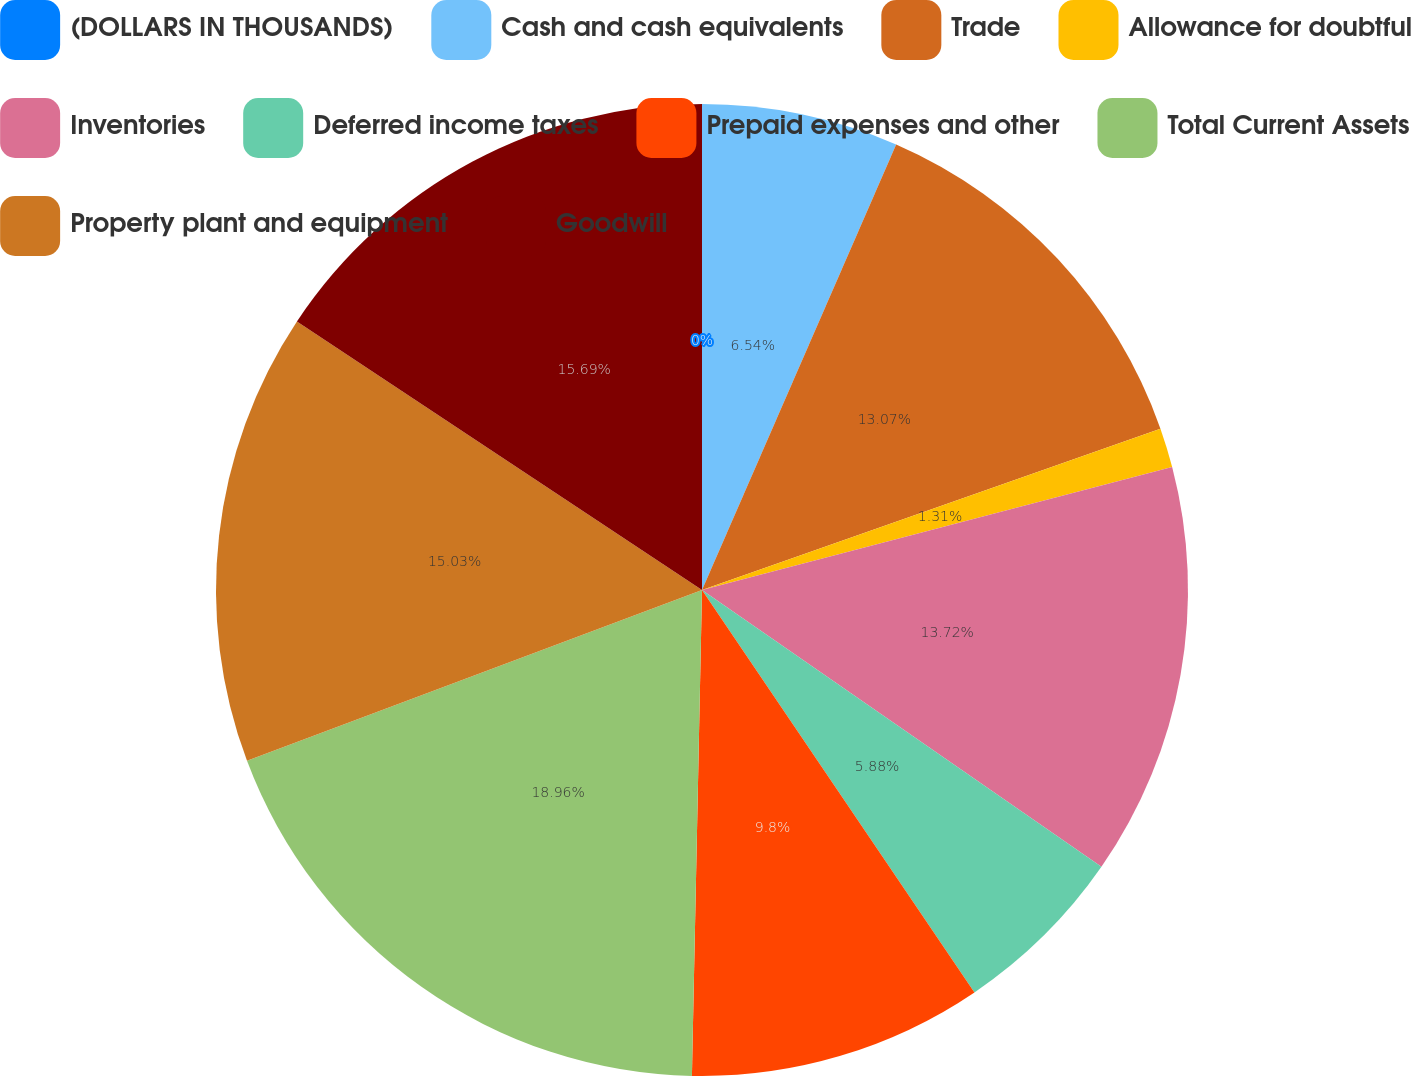<chart> <loc_0><loc_0><loc_500><loc_500><pie_chart><fcel>(DOLLARS IN THOUSANDS)<fcel>Cash and cash equivalents<fcel>Trade<fcel>Allowance for doubtful<fcel>Inventories<fcel>Deferred income taxes<fcel>Prepaid expenses and other<fcel>Total Current Assets<fcel>Property plant and equipment<fcel>Goodwill<nl><fcel>0.0%<fcel>6.54%<fcel>13.07%<fcel>1.31%<fcel>13.72%<fcel>5.88%<fcel>9.8%<fcel>18.95%<fcel>15.03%<fcel>15.68%<nl></chart> 